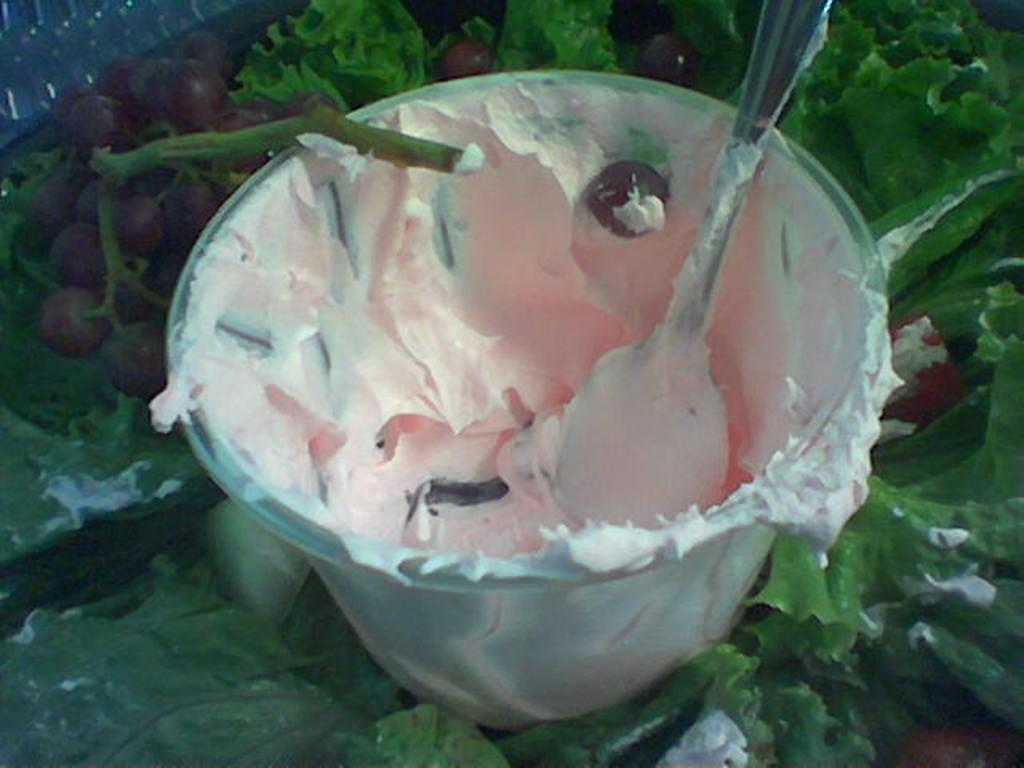What type of dessert is in the cup in the image? There is ice cream in a cup in the image. What utensil is used with the ice cream? There is a spoon in the ice cream. What type of fruit is present in the image? Grapes are present in the image. What type of plant material is visible in the image? Leaves are visible in the image. What books are being used to divide the grapes in the image? There are no books present in the image, nor are any books being used to divide the grapes. 